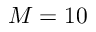Convert formula to latex. <formula><loc_0><loc_0><loc_500><loc_500>M = 1 0</formula> 